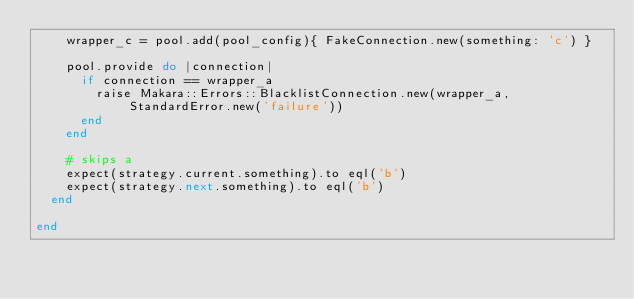Convert code to text. <code><loc_0><loc_0><loc_500><loc_500><_Ruby_>    wrapper_c = pool.add(pool_config){ FakeConnection.new(something: 'c') }

    pool.provide do |connection|
      if connection == wrapper_a
        raise Makara::Errors::BlacklistConnection.new(wrapper_a, StandardError.new('failure'))
      end
    end

    # skips a
    expect(strategy.current.something).to eql('b')
    expect(strategy.next.something).to eql('b')
  end

end
</code> 